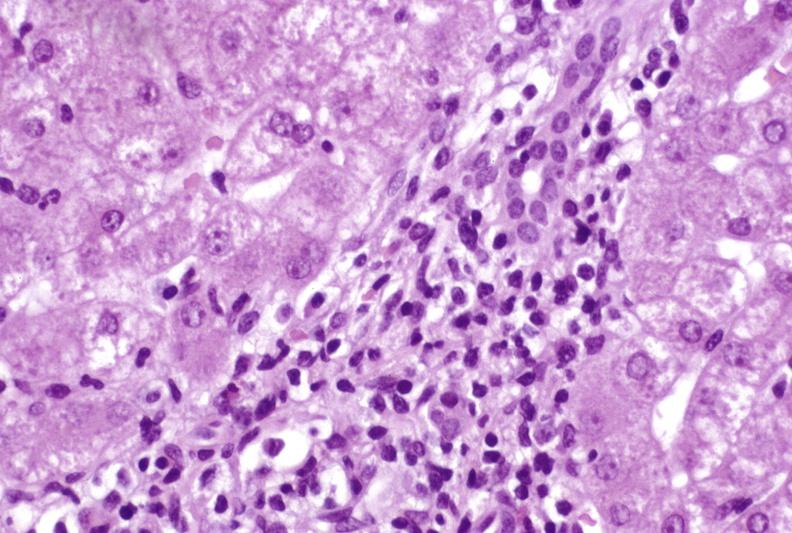what does this image show?
Answer the question using a single word or phrase. Moderate acute rejection 